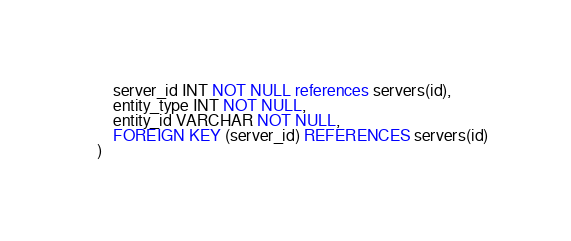<code> <loc_0><loc_0><loc_500><loc_500><_SQL_>    server_id INT NOT NULL references servers(id),
    entity_type INT NOT NULL,
    entity_id VARCHAR NOT NULL,
    FOREIGN KEY (server_id) REFERENCES servers(id)
)</code> 